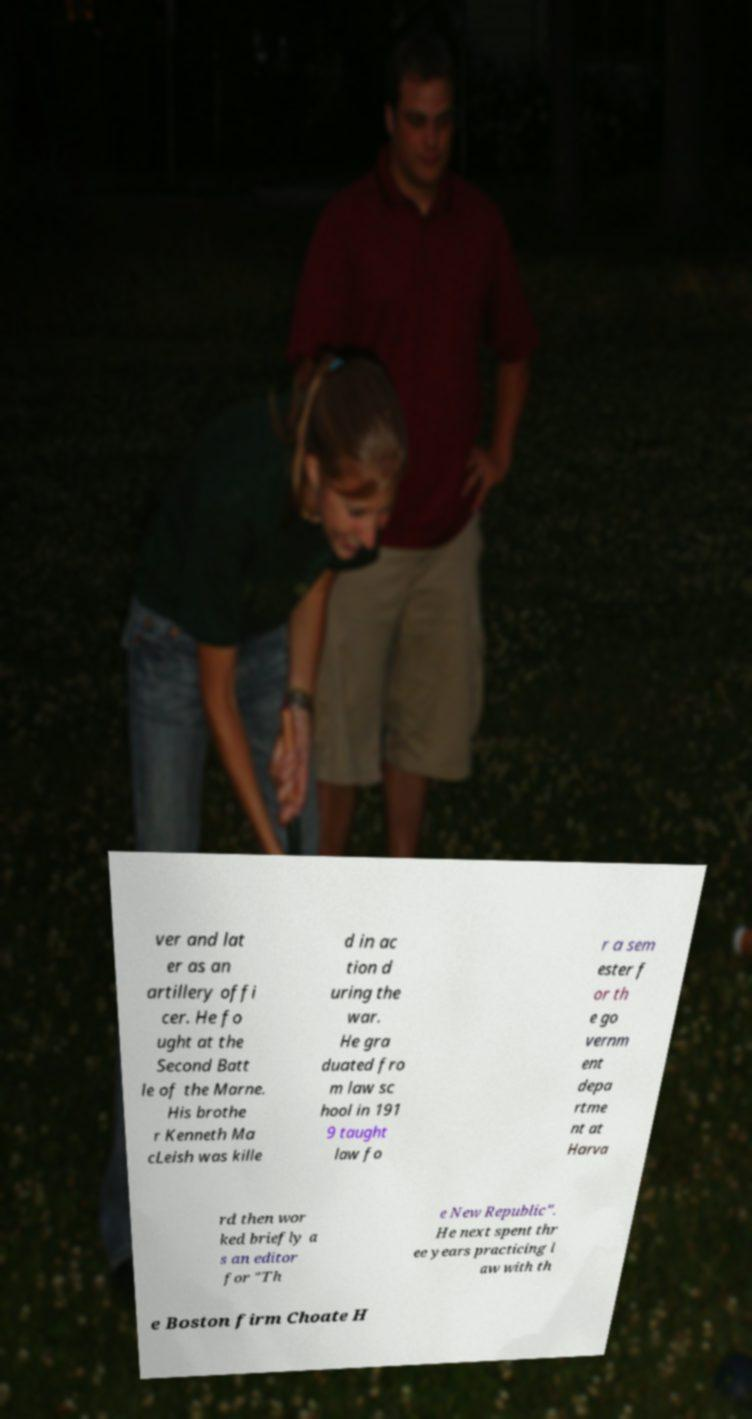Could you extract and type out the text from this image? ver and lat er as an artillery offi cer. He fo ught at the Second Batt le of the Marne. His brothe r Kenneth Ma cLeish was kille d in ac tion d uring the war. He gra duated fro m law sc hool in 191 9 taught law fo r a sem ester f or th e go vernm ent depa rtme nt at Harva rd then wor ked briefly a s an editor for "Th e New Republic". He next spent thr ee years practicing l aw with th e Boston firm Choate H 